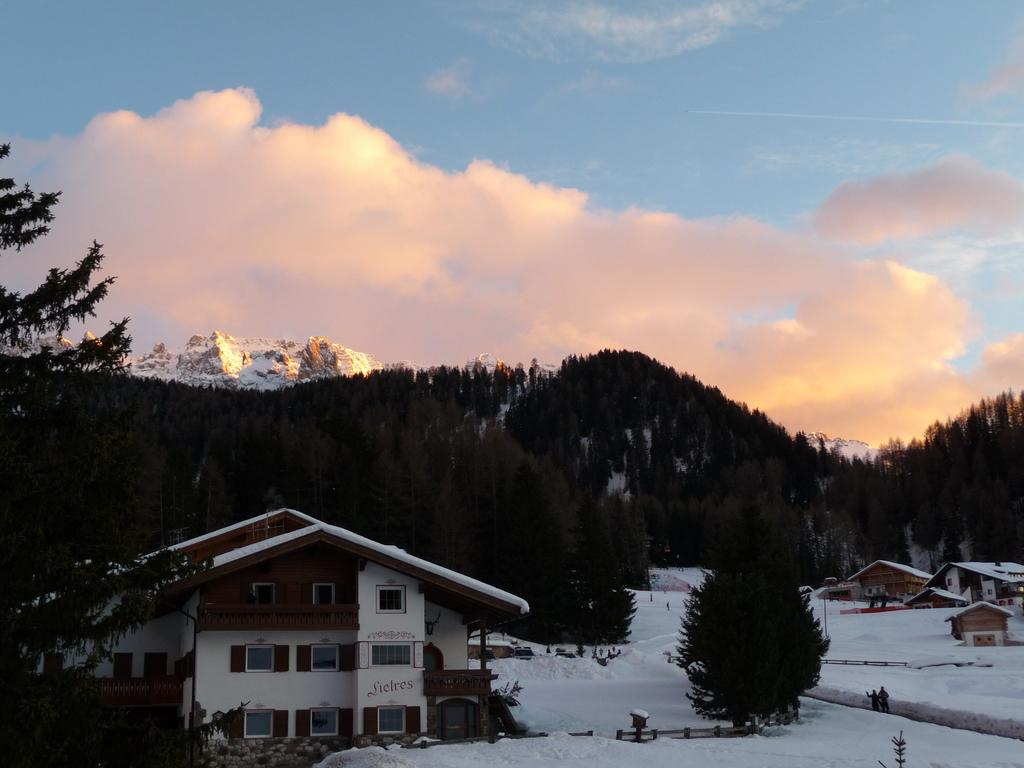What type of structures are present in the image? There are buildings with windows in the image. What is the weather like in the image? There is snow visible in the image, indicating a cold or wintry environment. What type of natural features can be seen in the image? There are trees and mountains in the image. How many people are in the image? Two people are standing in the image. What is visible in the background of the image? The sky is visible in the background of the image, with clouds present. What type of alarm can be heard going off in the image? There is no alarm present in the image, and therefore no sound can be heard. Can you tell me how many letters are on the cat in the image? There is no cat present in the image, and therefore no letters can be observed on one. 